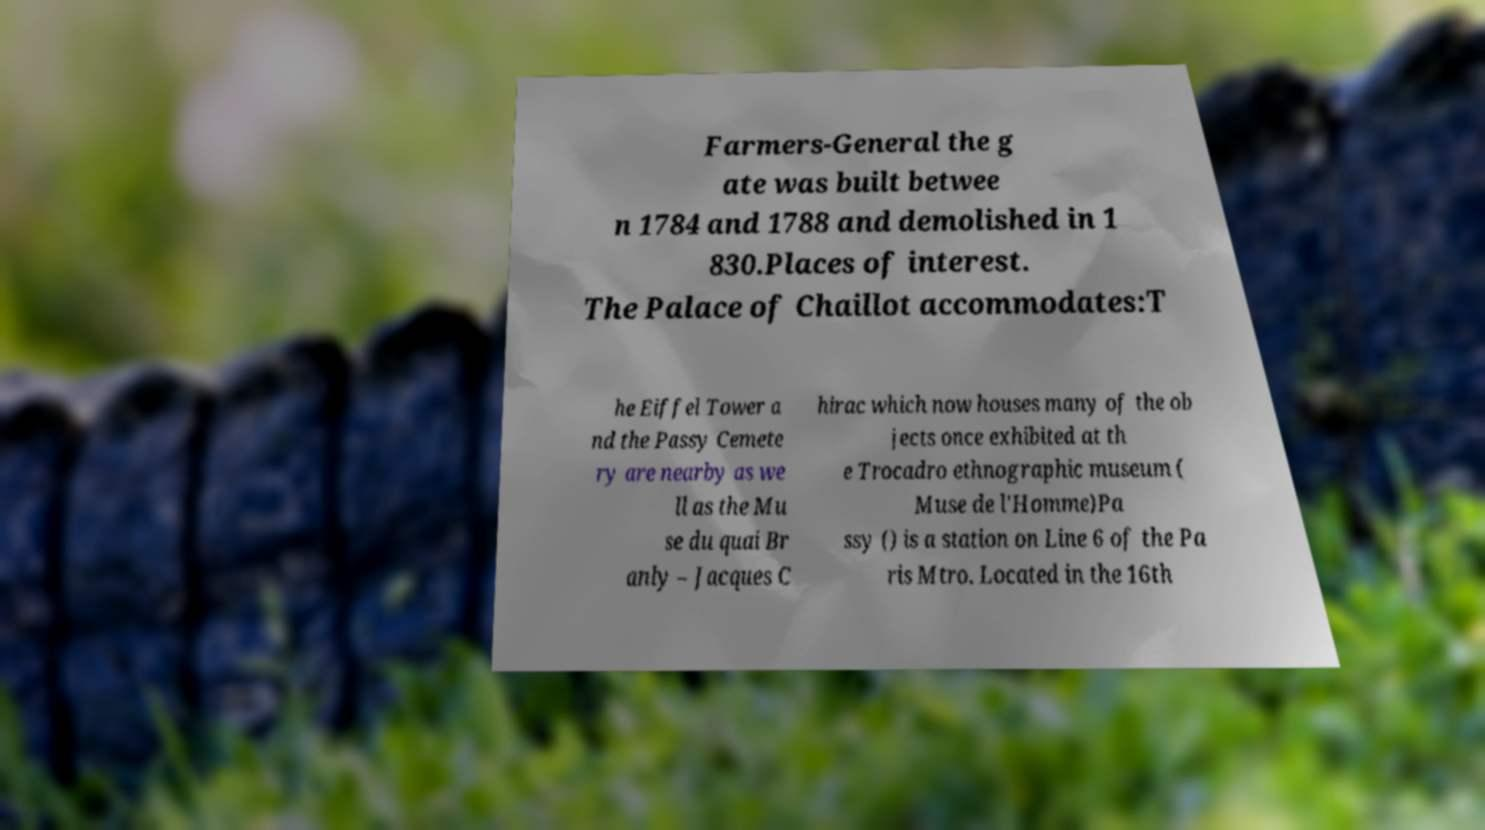Could you assist in decoding the text presented in this image and type it out clearly? Farmers-General the g ate was built betwee n 1784 and 1788 and demolished in 1 830.Places of interest. The Palace of Chaillot accommodates:T he Eiffel Tower a nd the Passy Cemete ry are nearby as we ll as the Mu se du quai Br anly – Jacques C hirac which now houses many of the ob jects once exhibited at th e Trocadro ethnographic museum ( Muse de l'Homme)Pa ssy () is a station on Line 6 of the Pa ris Mtro. Located in the 16th 